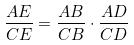<formula> <loc_0><loc_0><loc_500><loc_500>\frac { A E } { C E } = \frac { A B } { C B } \cdot \frac { A D } { C D }</formula> 